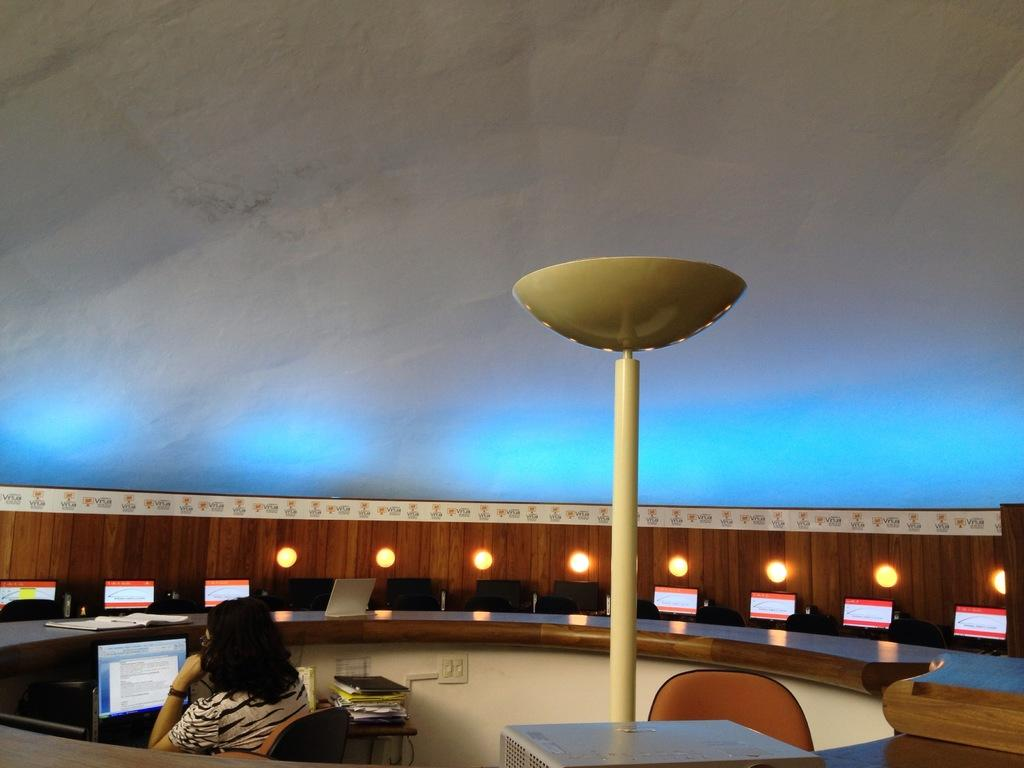What is the person in the image doing? The person is sitting in front of a monitor. Can you describe the lighting in the image? Yes, there are lights in the image. What type of wall can be seen behind the person in the image? There is no wall visible in the image; it only shows a person sitting in front of a monitor and lights. 